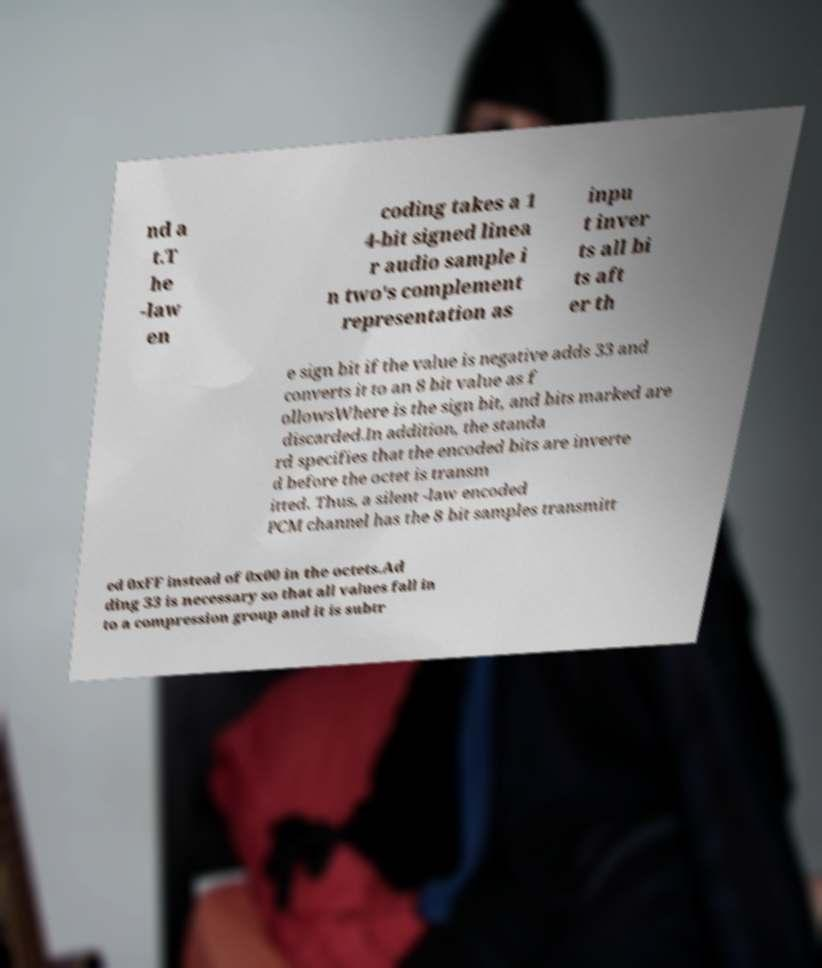For documentation purposes, I need the text within this image transcribed. Could you provide that? nd a t.T he -law en coding takes a 1 4-bit signed linea r audio sample i n two's complement representation as inpu t inver ts all bi ts aft er th e sign bit if the value is negative adds 33 and converts it to an 8 bit value as f ollowsWhere is the sign bit, and bits marked are discarded.In addition, the standa rd specifies that the encoded bits are inverte d before the octet is transm itted. Thus, a silent -law encoded PCM channel has the 8 bit samples transmitt ed 0xFF instead of 0x00 in the octets.Ad ding 33 is necessary so that all values fall in to a compression group and it is subtr 